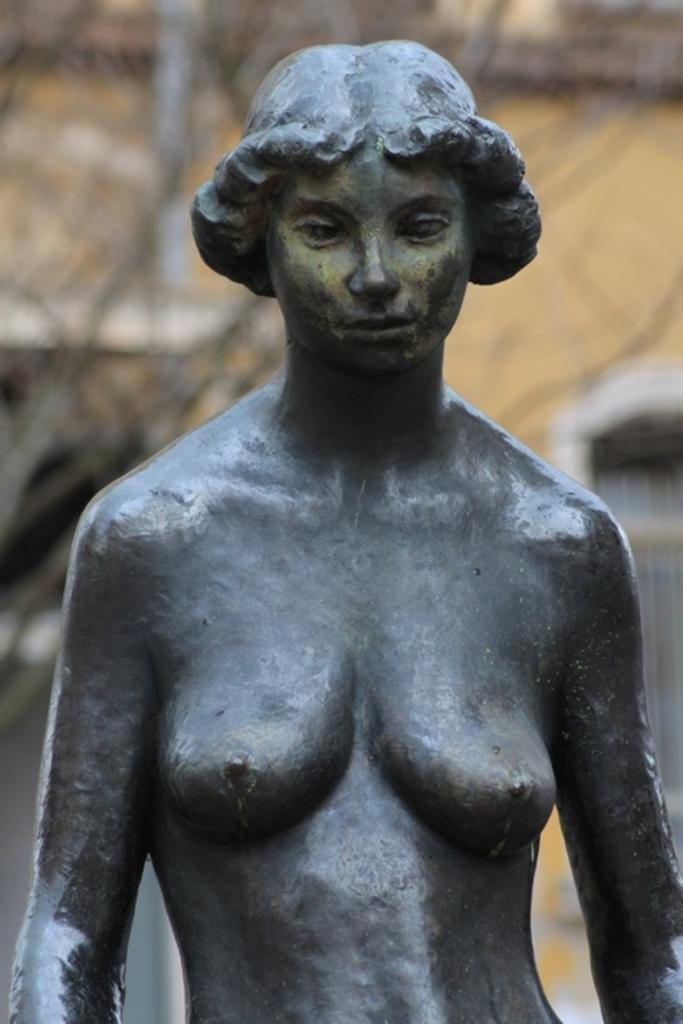What is the main subject in the center of the image? There is a sculpture in the center of the image. What can be seen in the background of the image? There is a building in the background of the image. Where is the window located in the image? There is a window visible on the right side of the image. What type of disease is being treated in the image? There is no indication of a disease or treatment in the image; it features a sculpture, a building, and a window. What type of humor can be seen in the image? There is no humor present in the image; it is a straightforward depiction of a sculpture, a building, and a window. 